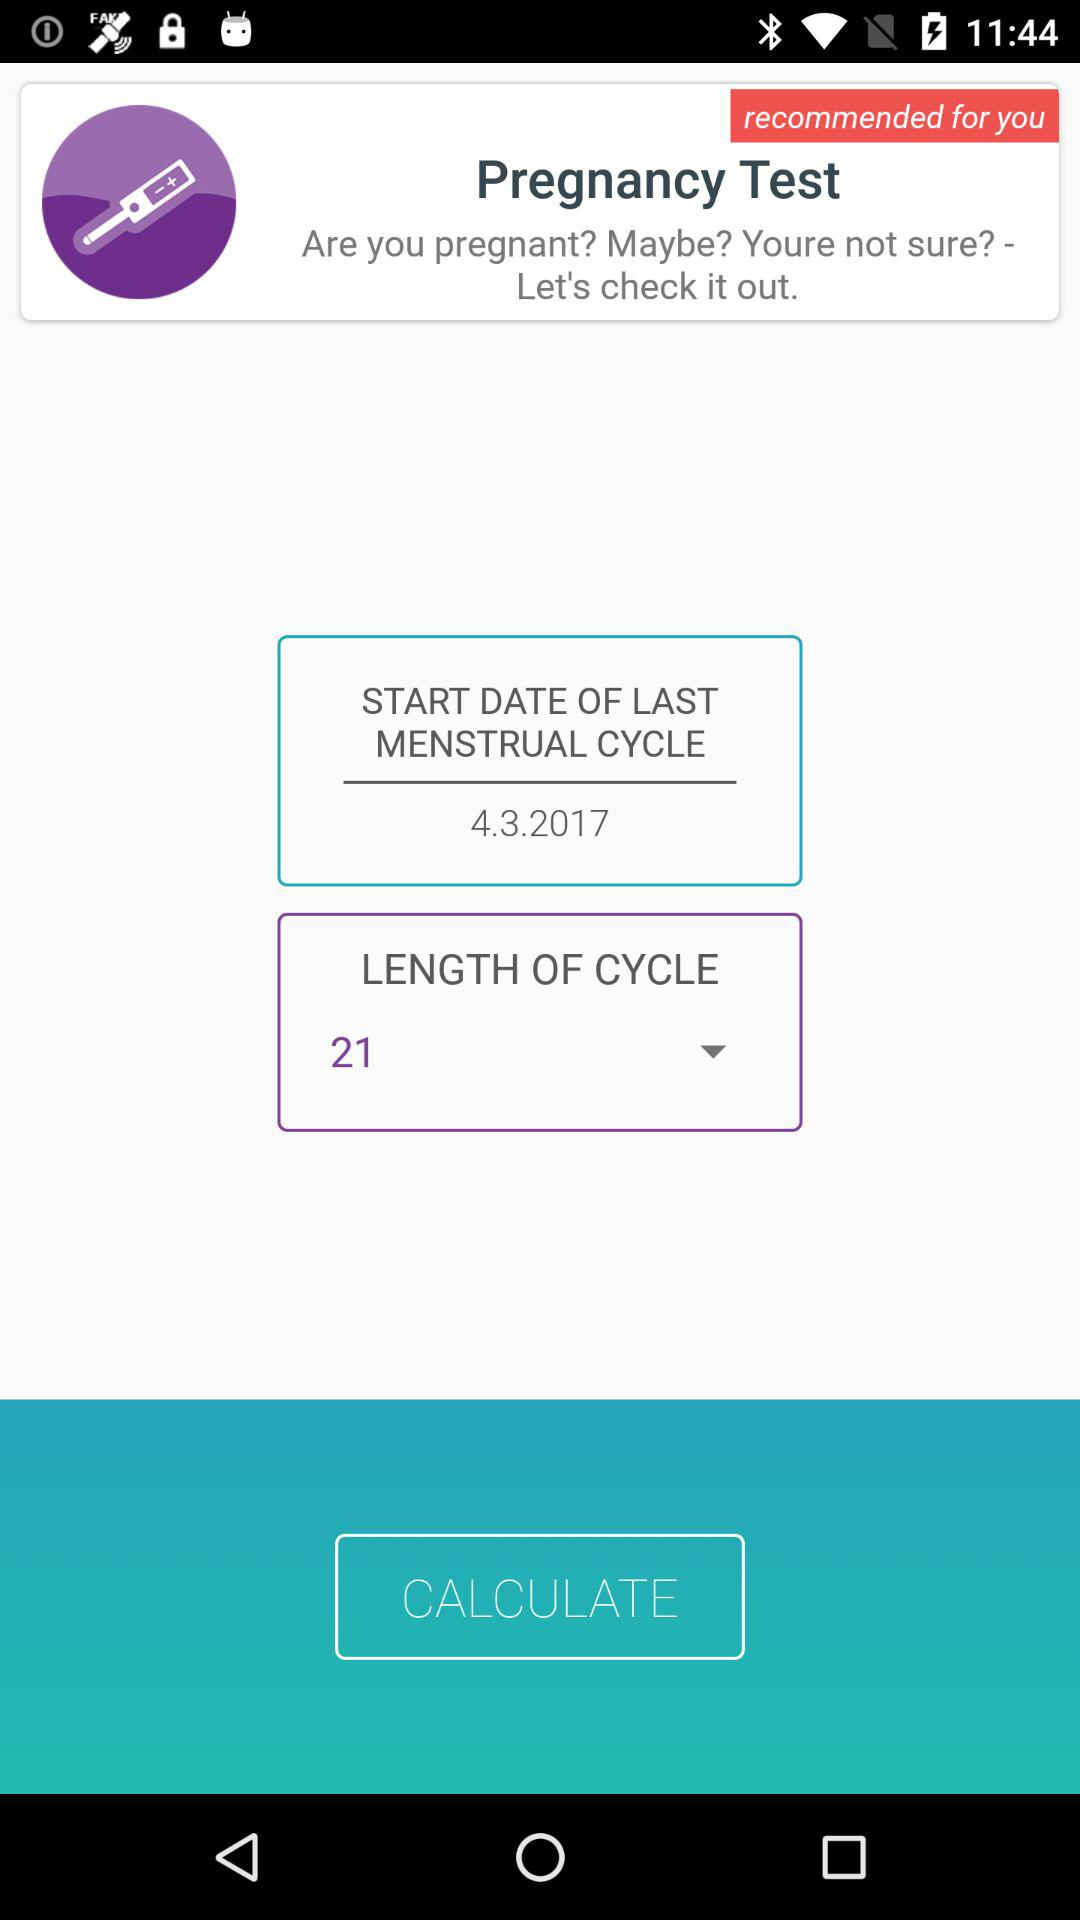What is the length of the cycle? The length of the cycle is 21. 